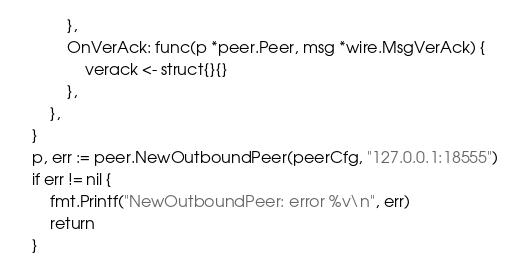Convert code to text. <code><loc_0><loc_0><loc_500><loc_500><_Go_>			},
			OnVerAck: func(p *peer.Peer, msg *wire.MsgVerAck) {
				verack <- struct{}{}
			},
		},
	}
	p, err := peer.NewOutboundPeer(peerCfg, "127.0.0.1:18555")
	if err != nil {
		fmt.Printf("NewOutboundPeer: error %v\n", err)
		return
	}
</code> 